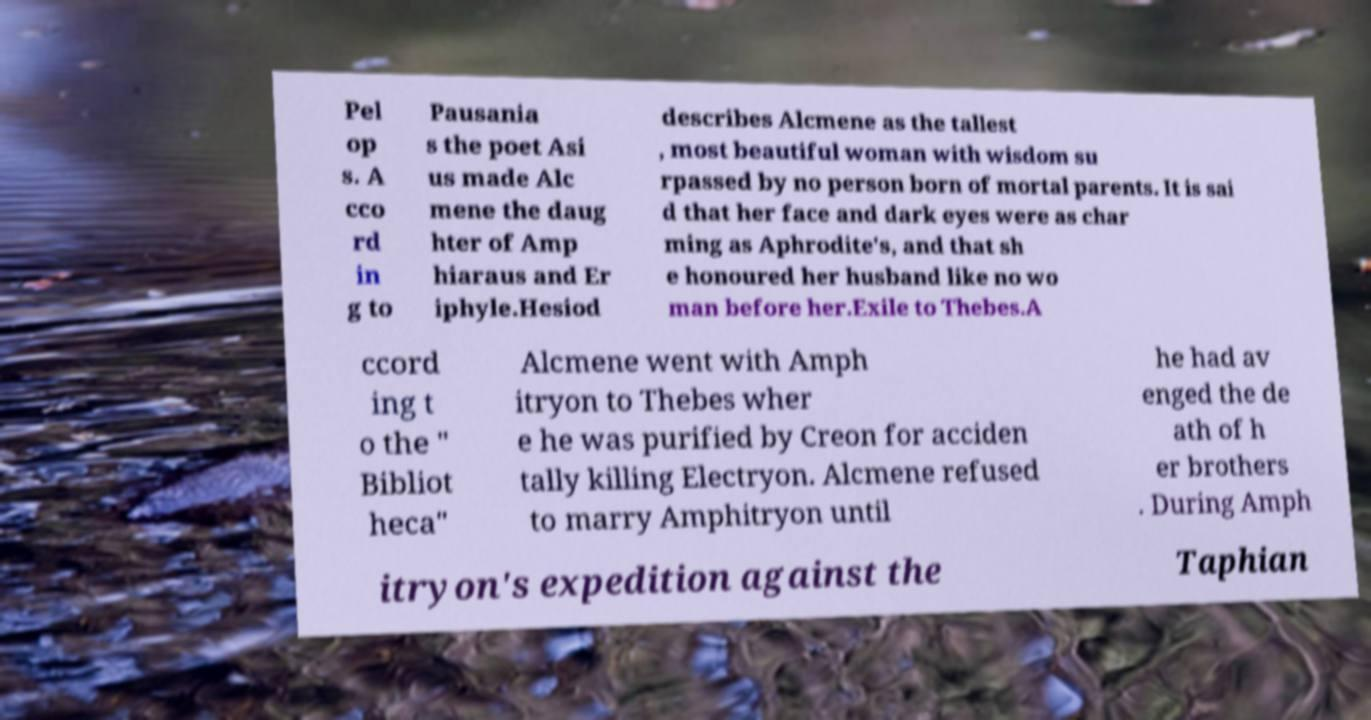What messages or text are displayed in this image? I need them in a readable, typed format. Pel op s. A cco rd in g to Pausania s the poet Asi us made Alc mene the daug hter of Amp hiaraus and Er iphyle.Hesiod describes Alcmene as the tallest , most beautiful woman with wisdom su rpassed by no person born of mortal parents. It is sai d that her face and dark eyes were as char ming as Aphrodite's, and that sh e honoured her husband like no wo man before her.Exile to Thebes.A ccord ing t o the " Bibliot heca" Alcmene went with Amph itryon to Thebes wher e he was purified by Creon for acciden tally killing Electryon. Alcmene refused to marry Amphitryon until he had av enged the de ath of h er brothers . During Amph itryon's expedition against the Taphian 